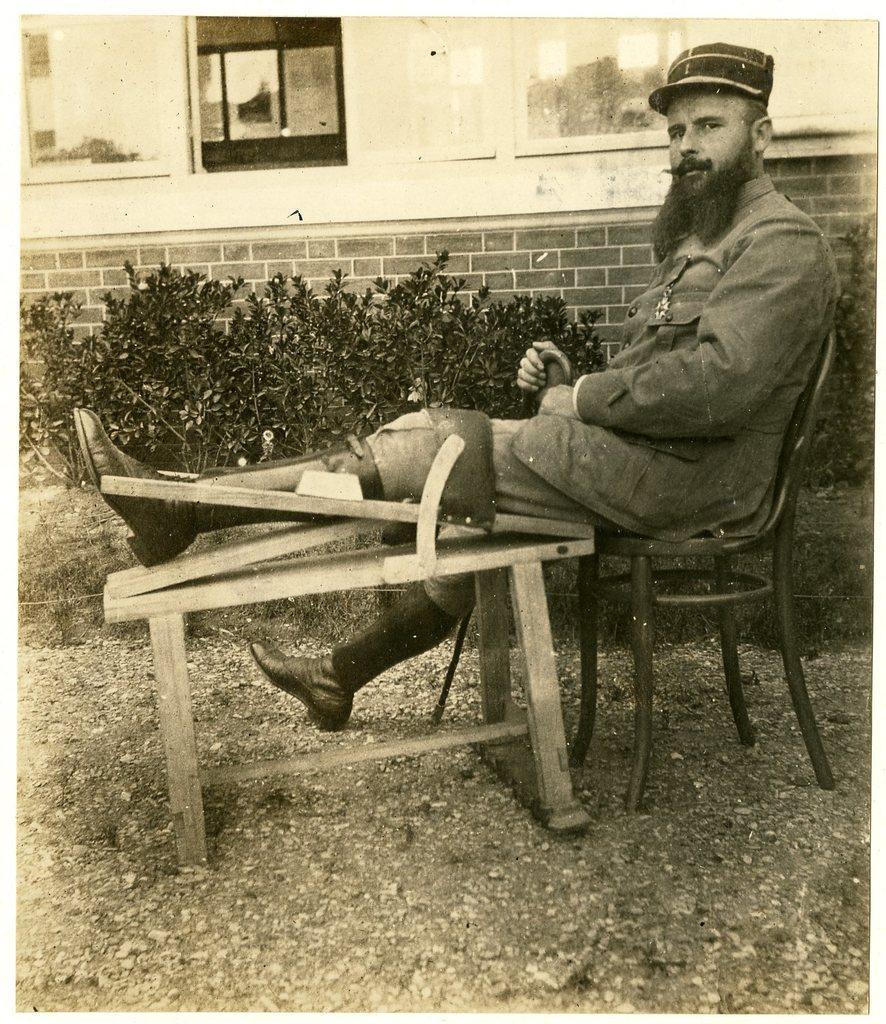Please provide a concise description of this image. In this image we can see a black and white picture of a person wearing uniform and hat is sitting on a chair. In the center of the image we can see a table. In the background, we can see group of plants and a building with windows. 